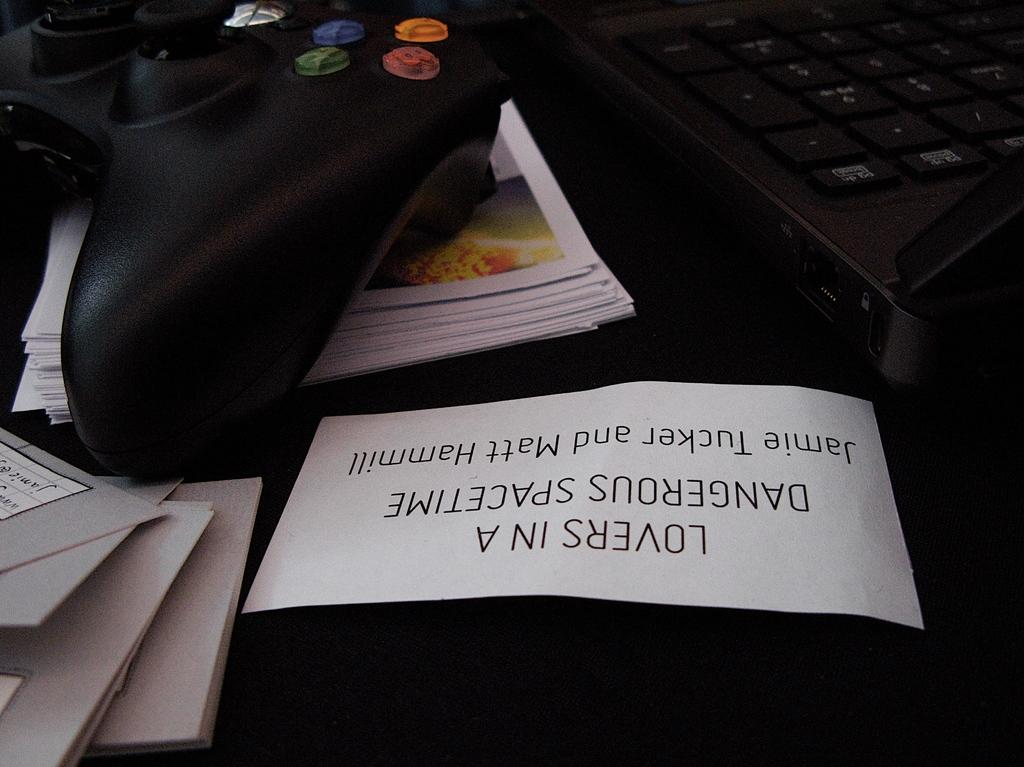<image>
Share a concise interpretation of the image provided. A video controller sits alongside a sign that reads lovers in a dangerous spacetime. 